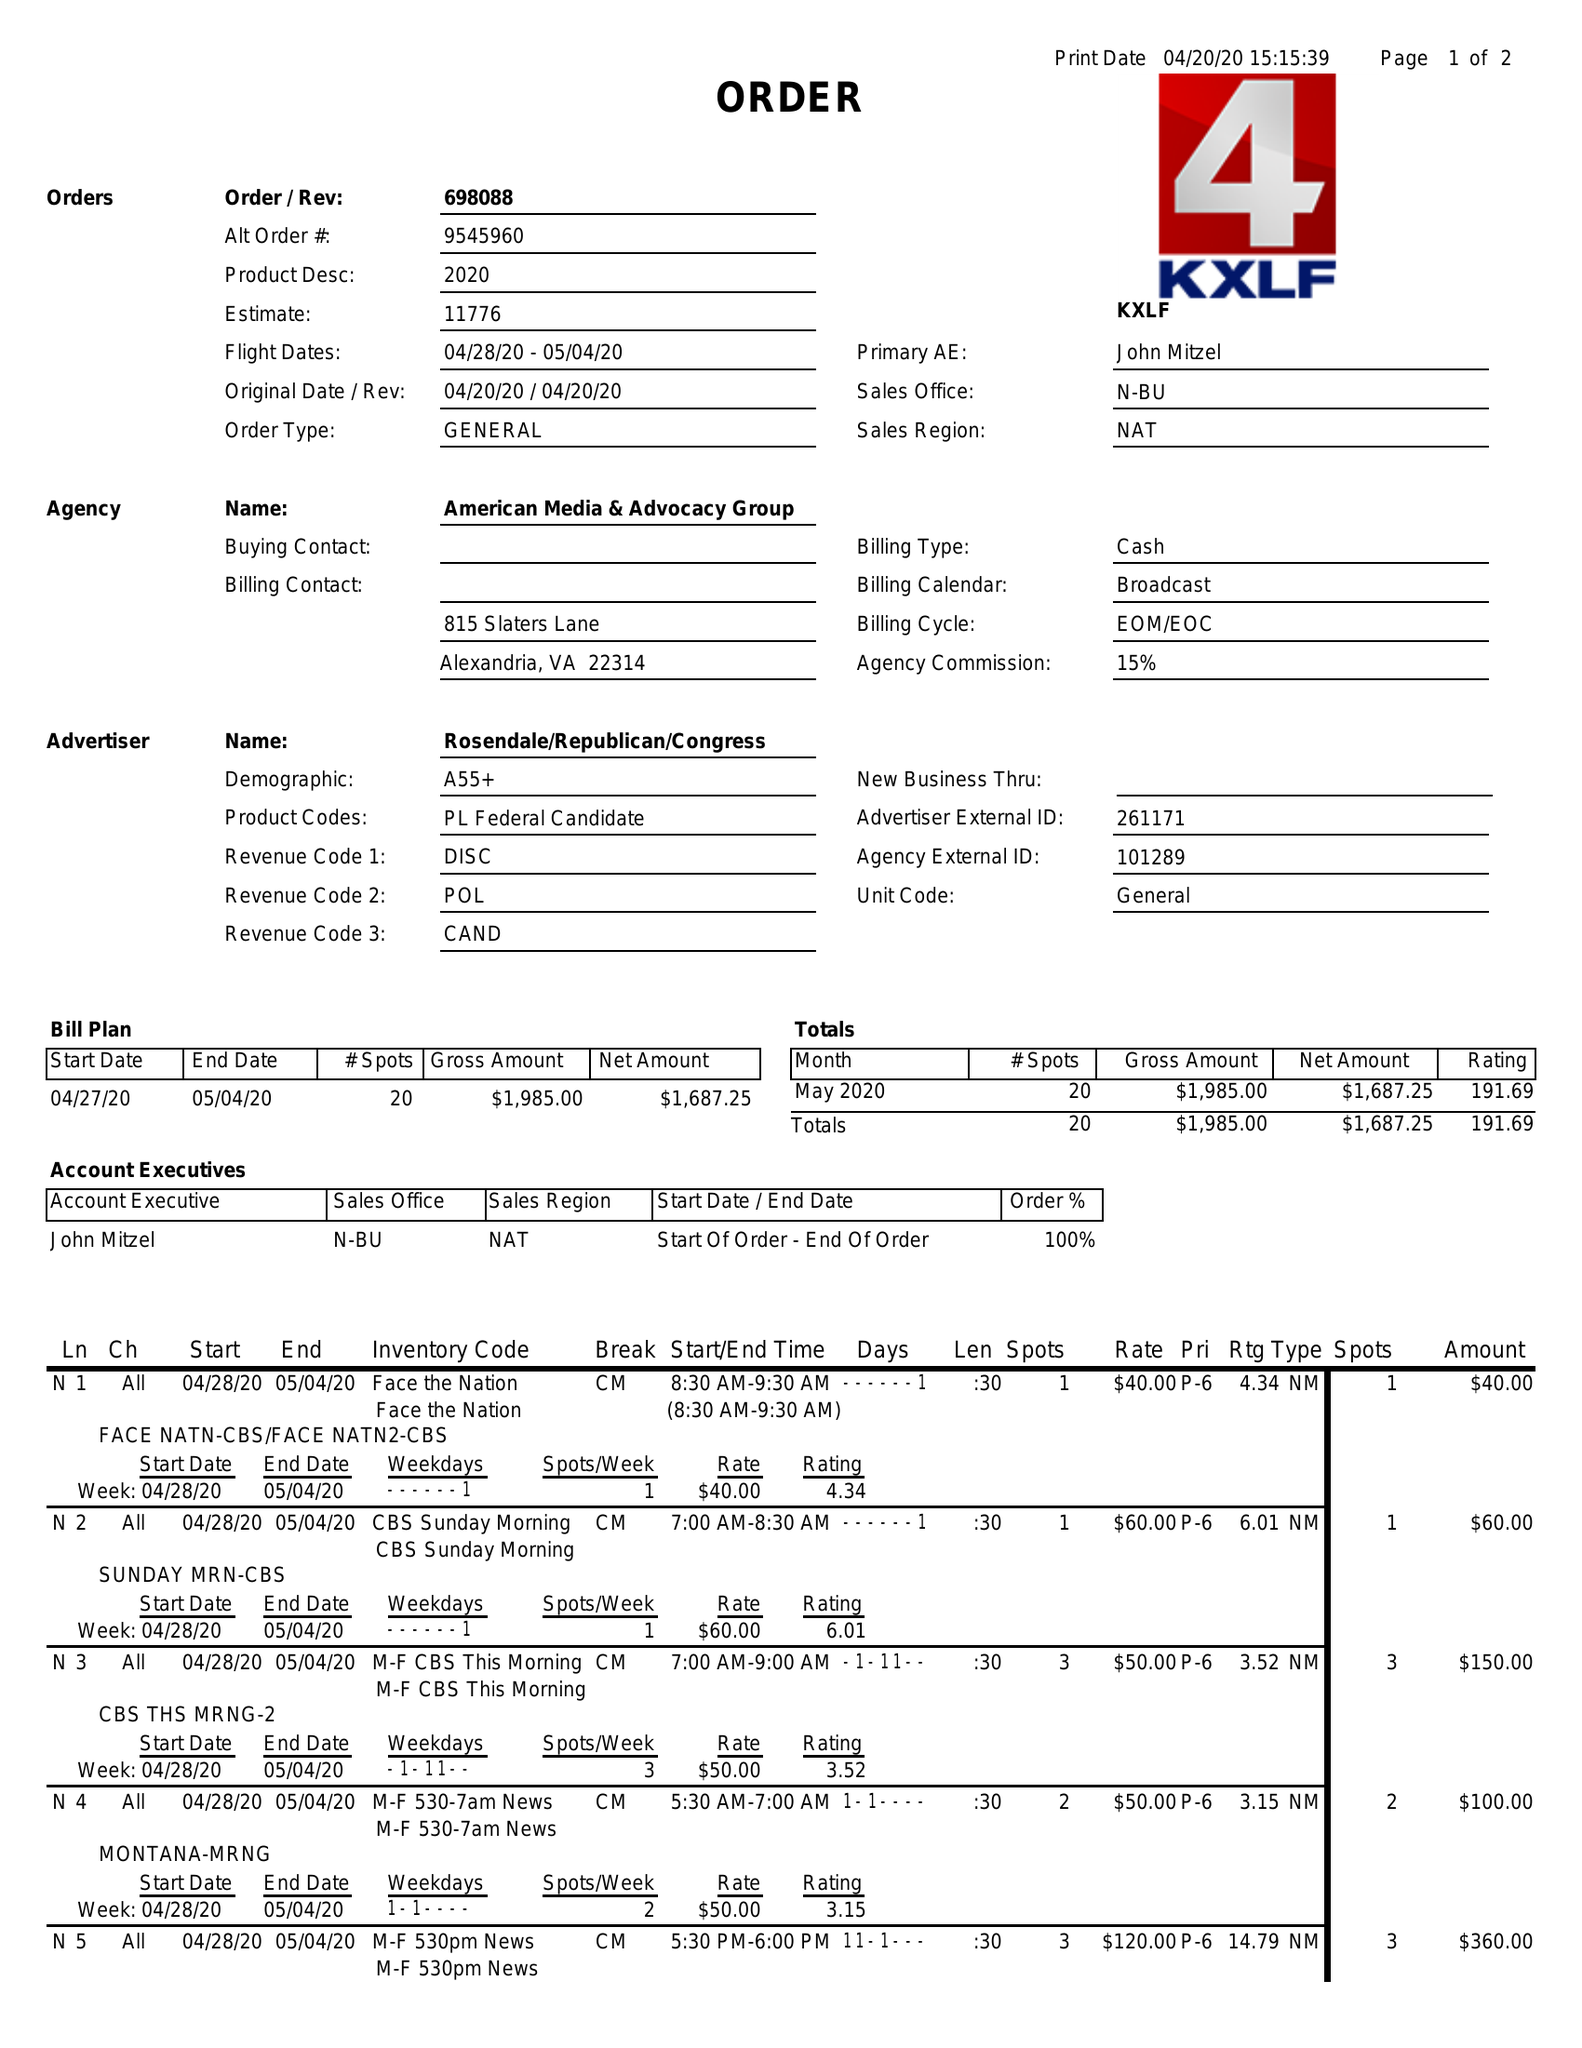What is the value for the advertiser?
Answer the question using a single word or phrase. ROSENDALE/REPUBLICAN/CONGRESS 